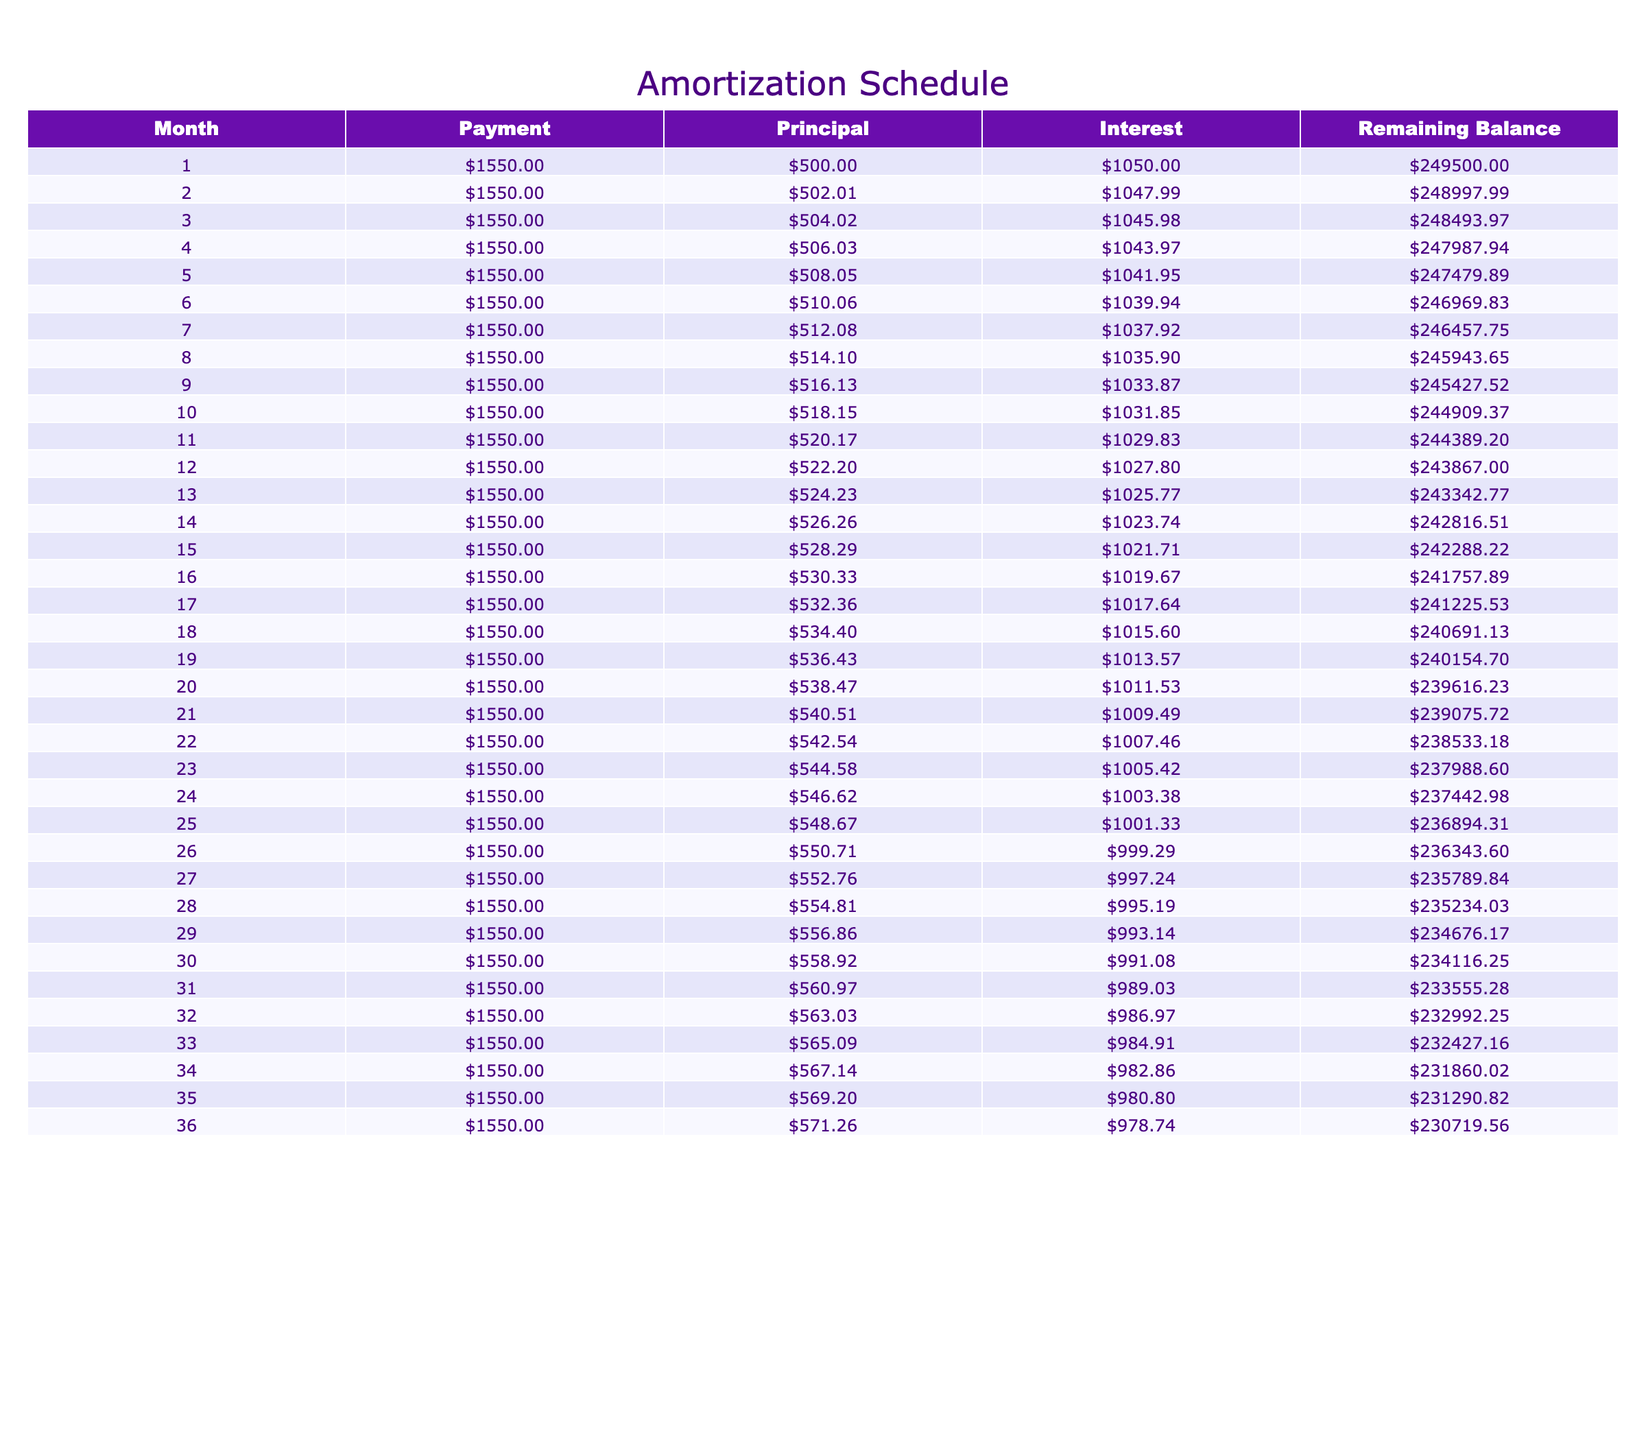What is the total principal repayment in the first three months? To find the total principal repayment in the first three months, we can sum the principal amounts for those months: 500.00 + 502.01 + 504.02 = 1506.03.
Answer: 1506.03 What is the interest paid in the 12th month? The interest paid in the 12th month is shown in the table and is 1027.80.
Answer: 1027.80 Is the payment amount the same every month? Yes, the payment amount of 1550.00 is consistent across all months, as indicated in every row of the table.
Answer: Yes What is the remaining balance after 25 months? The remaining balance after 25 months is listed in the table and is 236894.31.
Answer: 236894.31 What is the average monthly interest payment for the first 10 months? To find the average monthly interest payment for the first 10 months, we sum the interest amounts (1050.00 + 1047.99 + 1045.98 + 1043.97 + 1041.95 + 1039.94 + 1037.92 + 1035.90 + 1033.87 + 1031.85) which equals 10449.27. We then divide this total by 10, resulting in an average of 1044.93.
Answer: 1044.93 What was the change in remaining balance from month 1 to month 36? The remaining balance after the first month is 249500.00 and after the 36th month, it is 230719.56. To find the change, we subtract: 249500.00 - 230719.56 = 18780.44.
Answer: 18780.44 